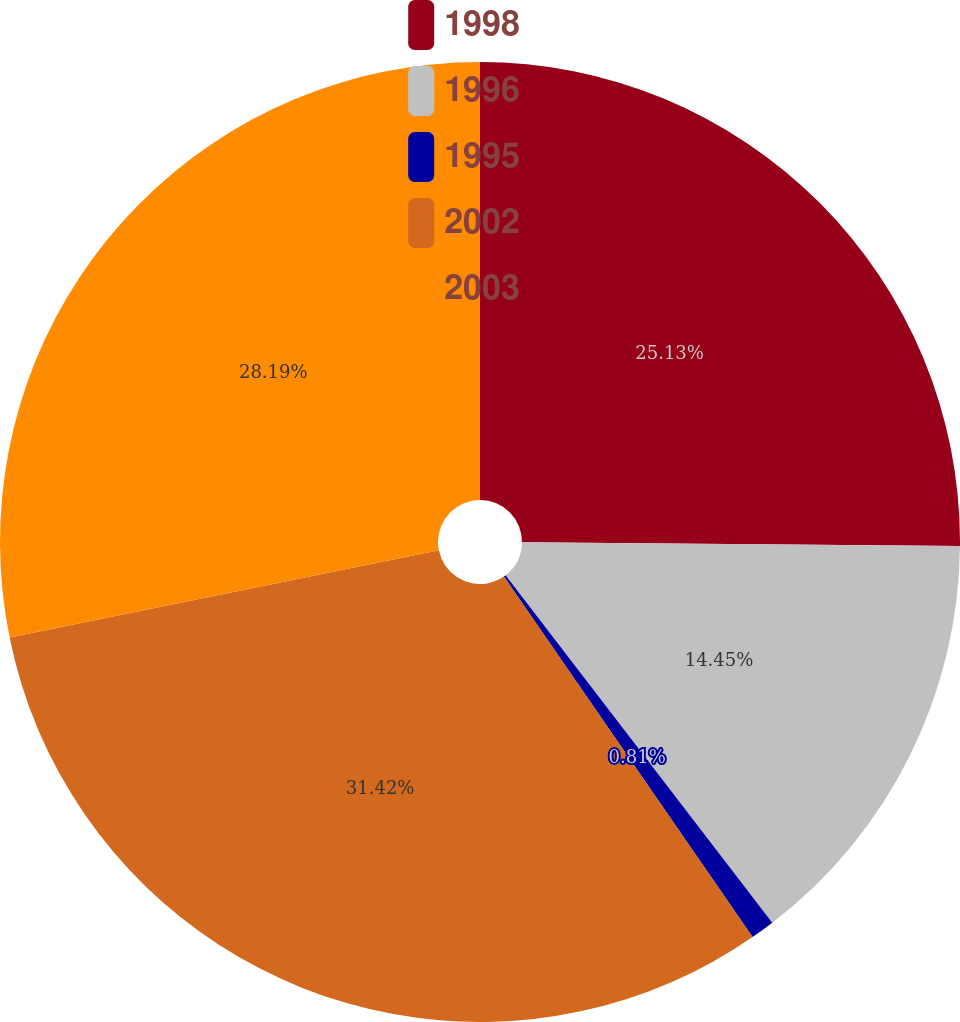Convert chart to OTSL. <chart><loc_0><loc_0><loc_500><loc_500><pie_chart><fcel>1998<fcel>1996<fcel>1995<fcel>2002<fcel>2003<nl><fcel>25.13%<fcel>14.45%<fcel>0.81%<fcel>31.42%<fcel>28.19%<nl></chart> 